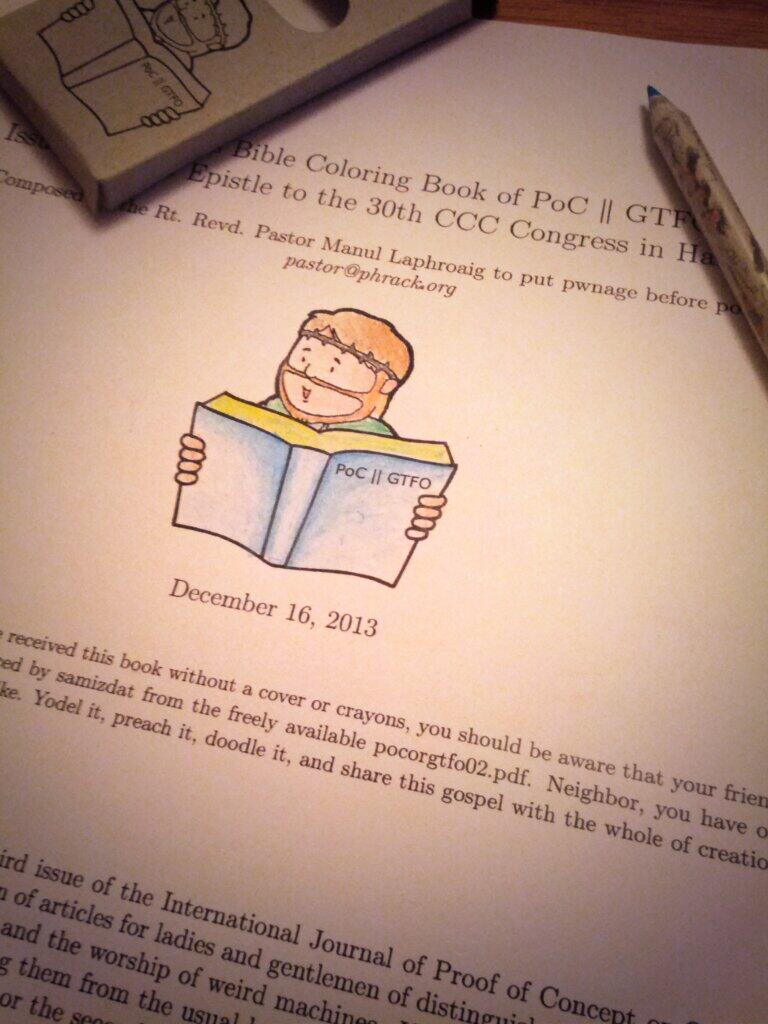<image>
Share a concise interpretation of the image provided. A page of paper titled Bible Cooloring Book of PoC 